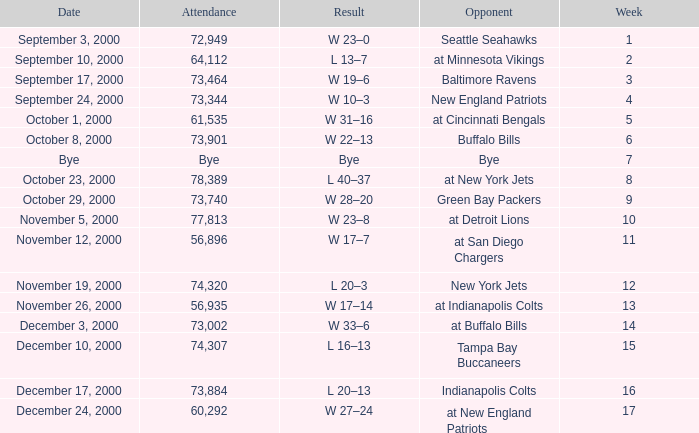What is the Attendance for a Week earlier than 16, and a Date of bye? Bye. 